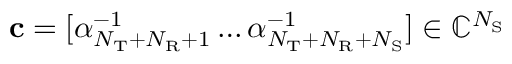Convert formula to latex. <formula><loc_0><loc_0><loc_500><loc_500>c = [ \alpha _ { N _ { T } + N _ { R } + 1 } ^ { - 1 } \dots \alpha _ { N _ { T } + N _ { R } + N _ { S } } ^ { - 1 } ] \in \mathbb { C } ^ { N _ { S } }</formula> 